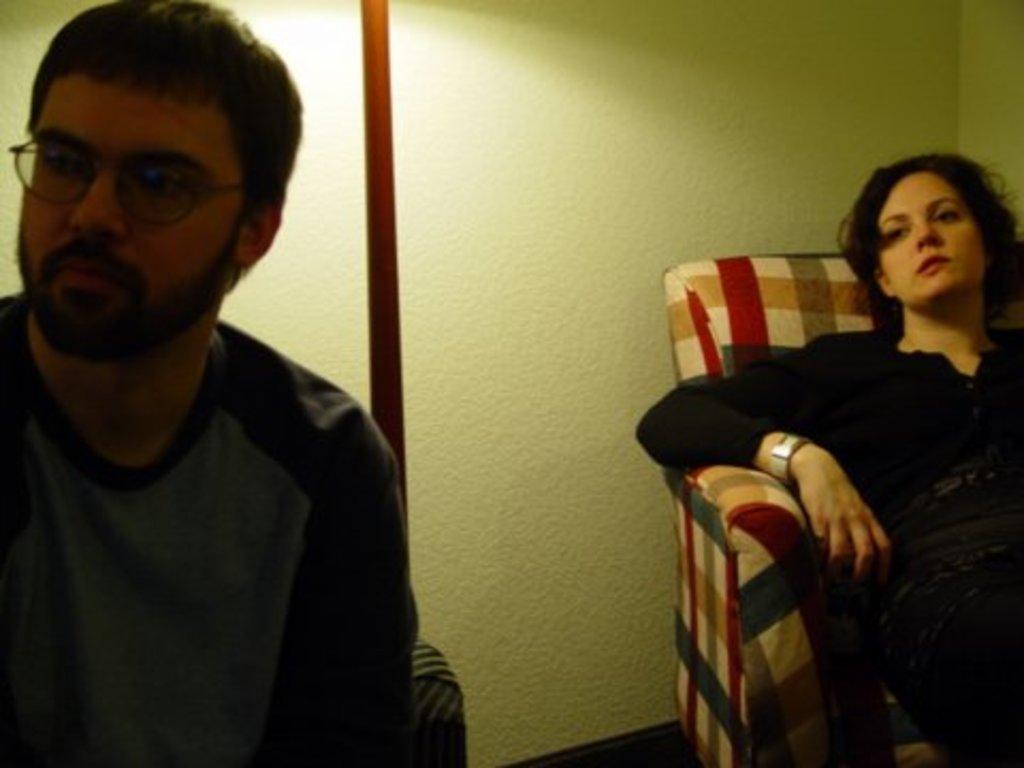In one or two sentences, can you explain what this image depicts? This is the picture of a room. On the left side of the image there is a man sitting on the chair. On the right side of the image there is a woman sitting on the chair. At the back there is a wall. 